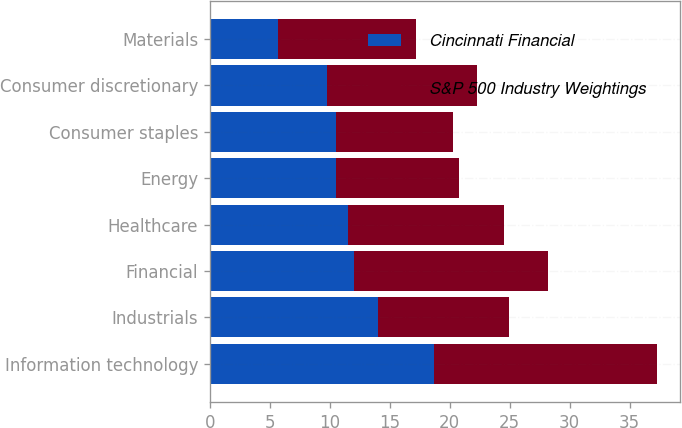<chart> <loc_0><loc_0><loc_500><loc_500><stacked_bar_chart><ecel><fcel>Information technology<fcel>Industrials<fcel>Financial<fcel>Healthcare<fcel>Energy<fcel>Consumer staples<fcel>Consumer discretionary<fcel>Materials<nl><fcel>Cincinnati Financial<fcel>18.7<fcel>14<fcel>12<fcel>11.5<fcel>10.5<fcel>10.5<fcel>9.8<fcel>5.7<nl><fcel>S&P 500 Industry Weightings<fcel>18.6<fcel>10.9<fcel>16.2<fcel>13<fcel>10.3<fcel>9.8<fcel>12.5<fcel>11.5<nl></chart> 